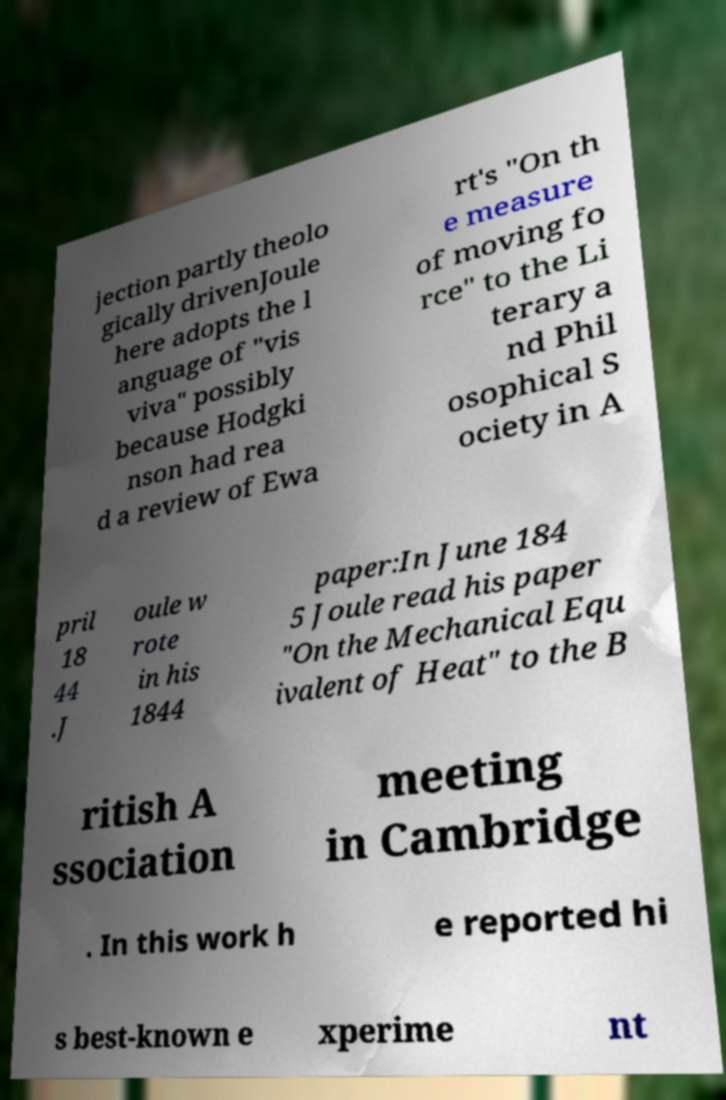Please identify and transcribe the text found in this image. jection partly theolo gically drivenJoule here adopts the l anguage of "vis viva" possibly because Hodgki nson had rea d a review of Ewa rt's "On th e measure of moving fo rce" to the Li terary a nd Phil osophical S ociety in A pril 18 44 .J oule w rote in his 1844 paper:In June 184 5 Joule read his paper "On the Mechanical Equ ivalent of Heat" to the B ritish A ssociation meeting in Cambridge . In this work h e reported hi s best-known e xperime nt 